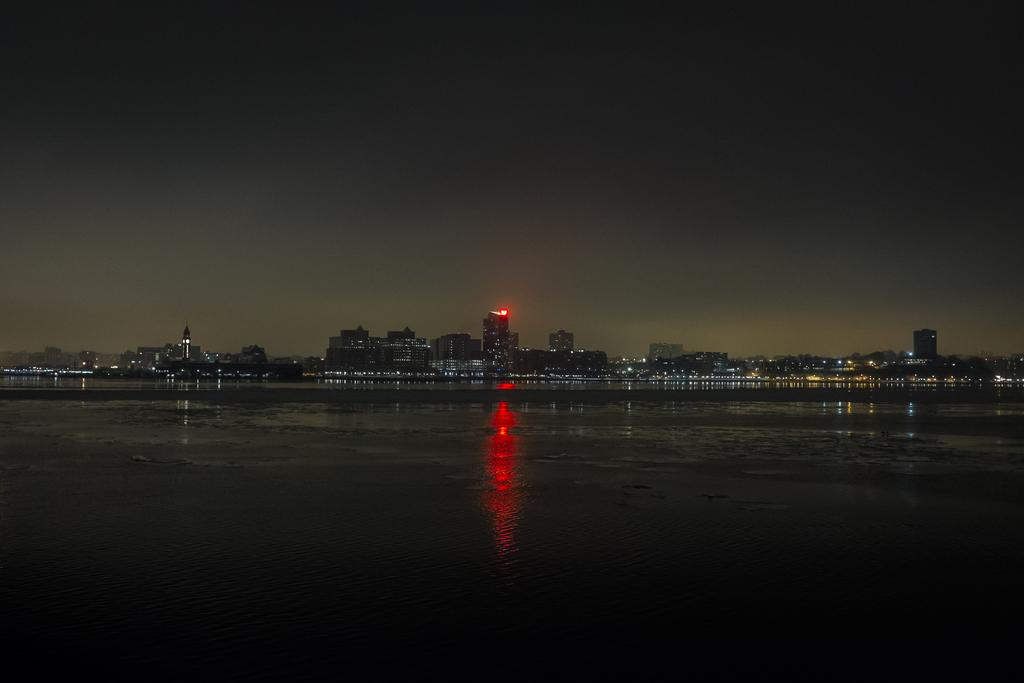What type of view is shown in the image? The image depicts a night view of the city. What structures can be seen in the image? There are buildings visible in the image. What is illuminating the scene in the image? There are lights in the image. What is the color of the sky in the image? The sky is dark in the image. Can you see any snails crawling on the buildings in the image? There are no snails visible in the image; it depicts a cityscape at night. 